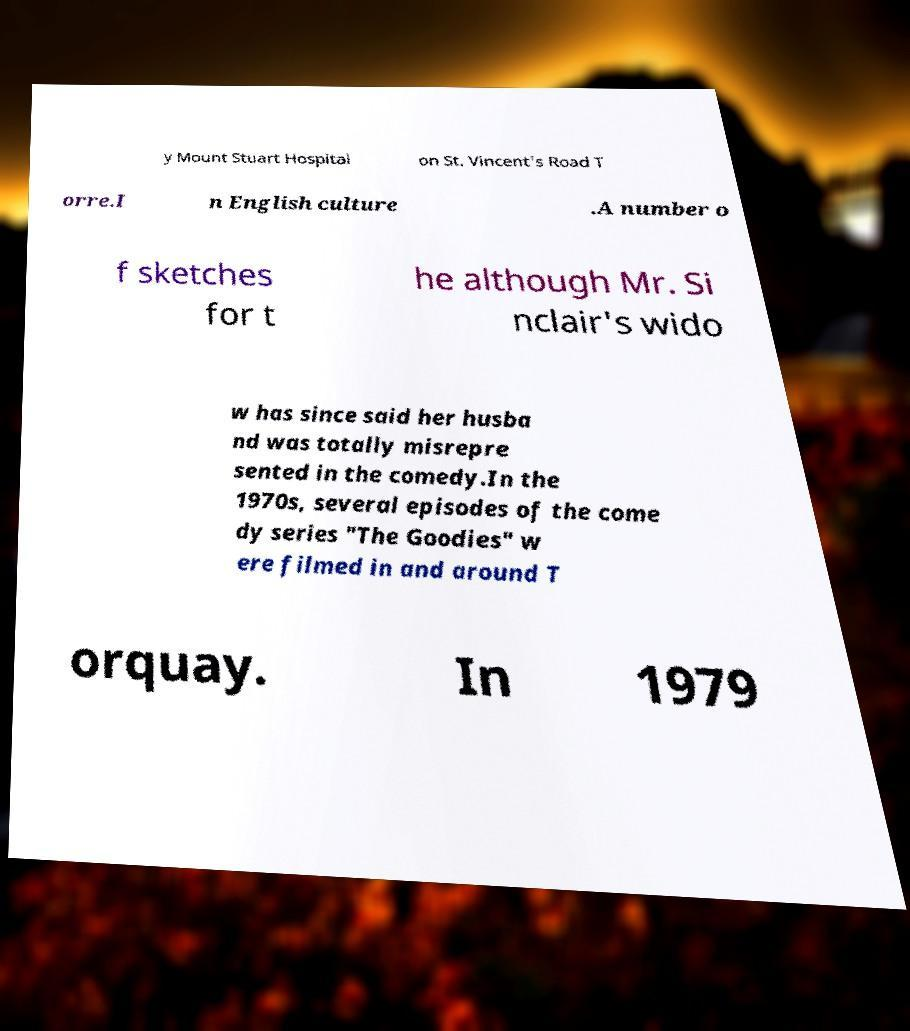I need the written content from this picture converted into text. Can you do that? y Mount Stuart Hospital on St. Vincent's Road T orre.I n English culture .A number o f sketches for t he although Mr. Si nclair's wido w has since said her husba nd was totally misrepre sented in the comedy.In the 1970s, several episodes of the come dy series "The Goodies" w ere filmed in and around T orquay. In 1979 